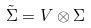Convert formula to latex. <formula><loc_0><loc_0><loc_500><loc_500>\tilde { \Sigma } = V \otimes \Sigma</formula> 